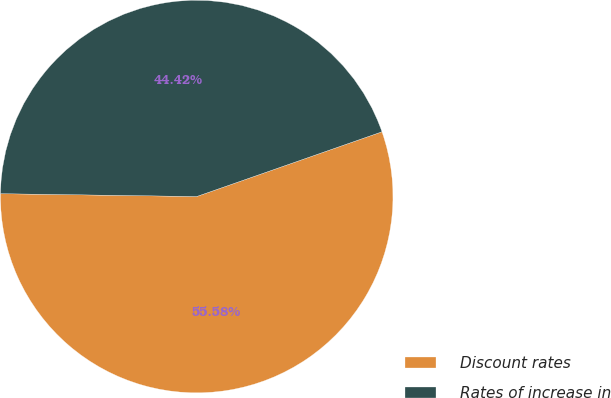<chart> <loc_0><loc_0><loc_500><loc_500><pie_chart><fcel>Discount rates<fcel>Rates of increase in<nl><fcel>55.58%<fcel>44.42%<nl></chart> 